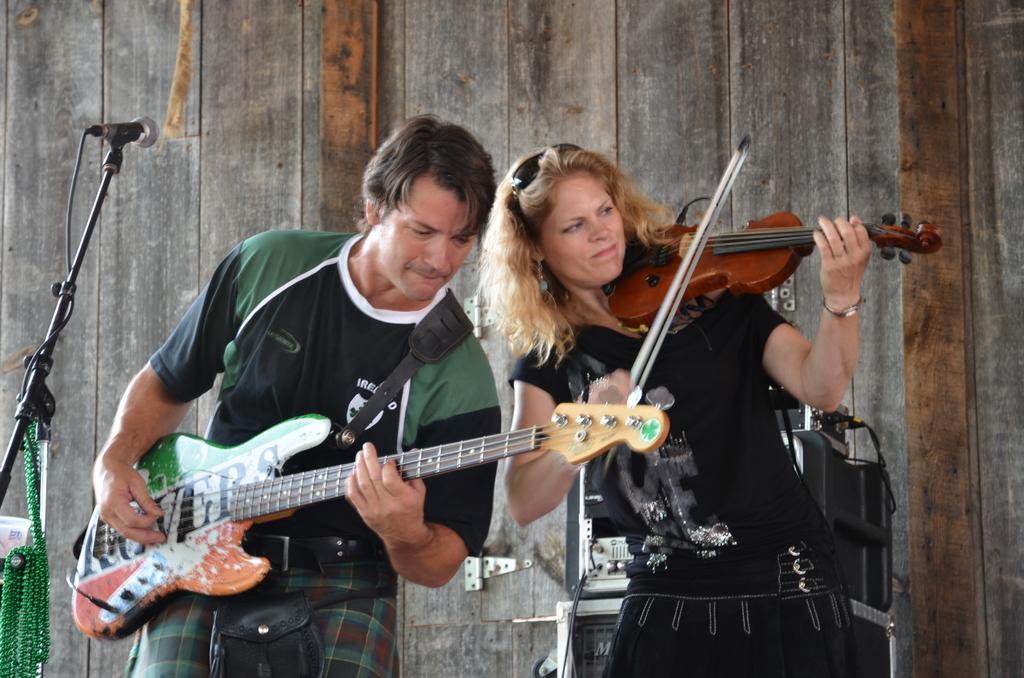Can you describe this image briefly? A man is playing guitar and beside him a woman is playing violin. 